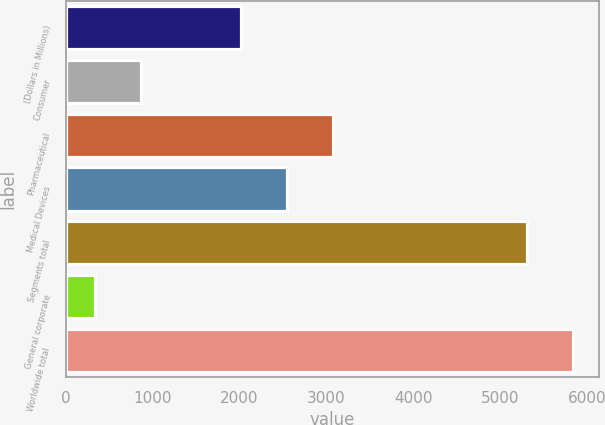Convert chart to OTSL. <chart><loc_0><loc_0><loc_500><loc_500><bar_chart><fcel>(Dollars in Millions)<fcel>Consumer<fcel>Pharmaceutical<fcel>Medical Devices<fcel>Segments total<fcel>General corporate<fcel>Worldwide total<nl><fcel>2017<fcel>866.6<fcel>3078.2<fcel>2547.6<fcel>5306<fcel>336<fcel>5836.6<nl></chart> 